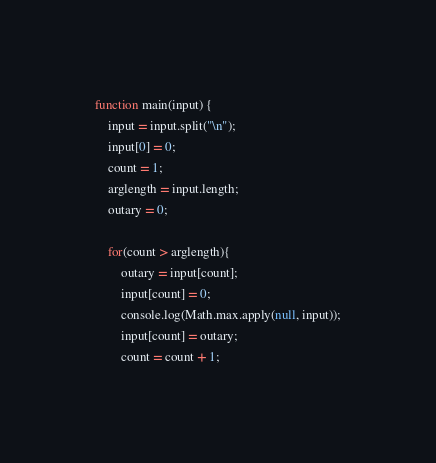Convert code to text. <code><loc_0><loc_0><loc_500><loc_500><_JavaScript_>function main(input) {
	input = input.split("\n");
	input[0] = 0;
	count = 1;
	arglength = input.length;
    outary = 0;

    for(count > arglength){
    	outary = input[count];
    	input[count] = 0;
    	console.log(Math.max.apply(null, input));
    	input[count] = outary;
    	count = count + 1;</code> 